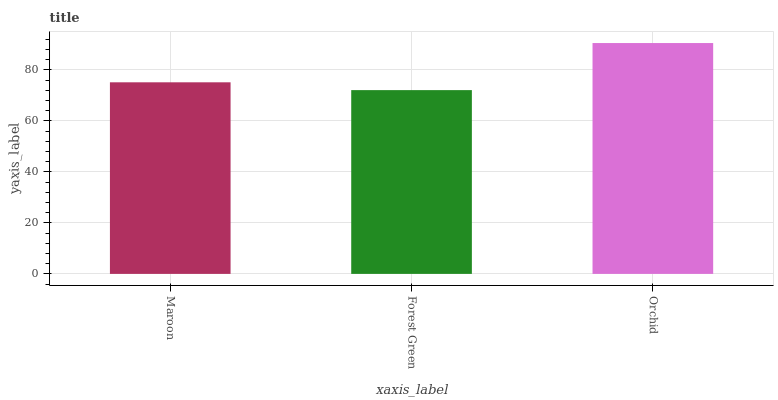Is Forest Green the minimum?
Answer yes or no. Yes. Is Orchid the maximum?
Answer yes or no. Yes. Is Orchid the minimum?
Answer yes or no. No. Is Forest Green the maximum?
Answer yes or no. No. Is Orchid greater than Forest Green?
Answer yes or no. Yes. Is Forest Green less than Orchid?
Answer yes or no. Yes. Is Forest Green greater than Orchid?
Answer yes or no. No. Is Orchid less than Forest Green?
Answer yes or no. No. Is Maroon the high median?
Answer yes or no. Yes. Is Maroon the low median?
Answer yes or no. Yes. Is Orchid the high median?
Answer yes or no. No. Is Orchid the low median?
Answer yes or no. No. 